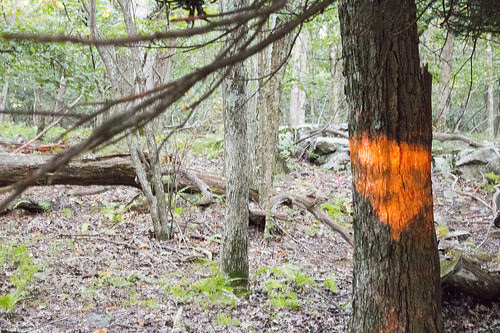<image>
Is there a stone on the ground? Yes. Looking at the image, I can see the stone is positioned on top of the ground, with the ground providing support. Where is the paint in relation to the tree? Is it in the tree? Yes. The paint is contained within or inside the tree, showing a containment relationship. 